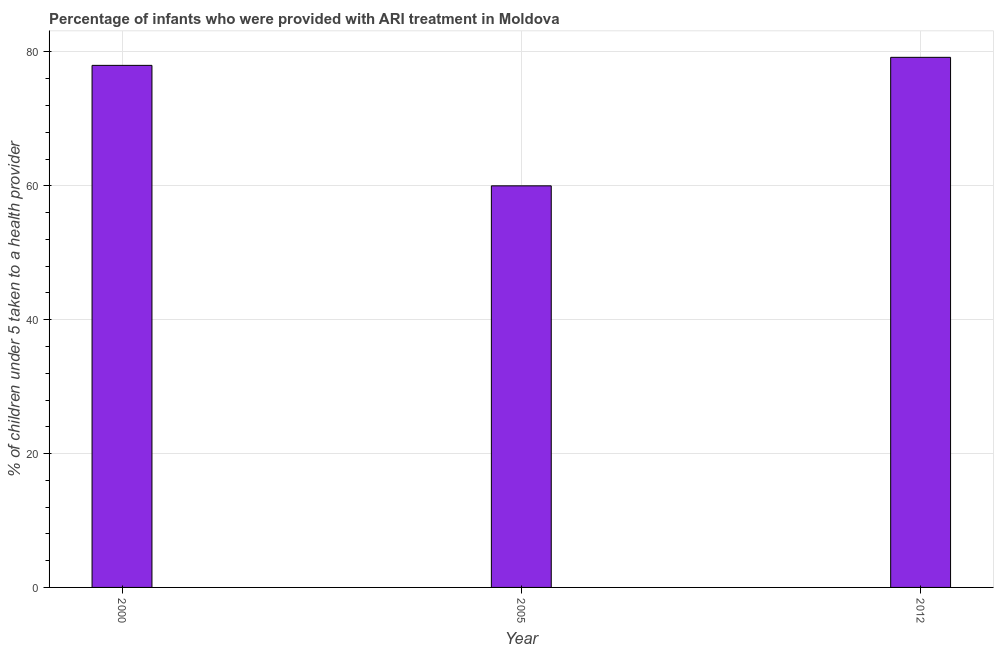What is the title of the graph?
Provide a succinct answer. Percentage of infants who were provided with ARI treatment in Moldova. What is the label or title of the Y-axis?
Your response must be concise. % of children under 5 taken to a health provider. What is the percentage of children who were provided with ari treatment in 2012?
Your answer should be compact. 79.2. Across all years, what is the maximum percentage of children who were provided with ari treatment?
Ensure brevity in your answer.  79.2. What is the sum of the percentage of children who were provided with ari treatment?
Your answer should be compact. 217.2. What is the difference between the percentage of children who were provided with ari treatment in 2005 and 2012?
Offer a terse response. -19.2. What is the average percentage of children who were provided with ari treatment per year?
Your answer should be compact. 72.4. What is the median percentage of children who were provided with ari treatment?
Offer a very short reply. 78. In how many years, is the percentage of children who were provided with ari treatment greater than 76 %?
Give a very brief answer. 2. Do a majority of the years between 2000 and 2012 (inclusive) have percentage of children who were provided with ari treatment greater than 76 %?
Provide a succinct answer. Yes. Is the percentage of children who were provided with ari treatment in 2000 less than that in 2005?
Offer a very short reply. No. Is the sum of the percentage of children who were provided with ari treatment in 2000 and 2005 greater than the maximum percentage of children who were provided with ari treatment across all years?
Your answer should be very brief. Yes. Are all the bars in the graph horizontal?
Your response must be concise. No. How many years are there in the graph?
Provide a short and direct response. 3. What is the difference between two consecutive major ticks on the Y-axis?
Offer a terse response. 20. Are the values on the major ticks of Y-axis written in scientific E-notation?
Give a very brief answer. No. What is the % of children under 5 taken to a health provider of 2000?
Provide a succinct answer. 78. What is the % of children under 5 taken to a health provider of 2005?
Offer a terse response. 60. What is the % of children under 5 taken to a health provider in 2012?
Provide a short and direct response. 79.2. What is the difference between the % of children under 5 taken to a health provider in 2000 and 2012?
Make the answer very short. -1.2. What is the difference between the % of children under 5 taken to a health provider in 2005 and 2012?
Offer a terse response. -19.2. What is the ratio of the % of children under 5 taken to a health provider in 2000 to that in 2012?
Give a very brief answer. 0.98. What is the ratio of the % of children under 5 taken to a health provider in 2005 to that in 2012?
Provide a succinct answer. 0.76. 